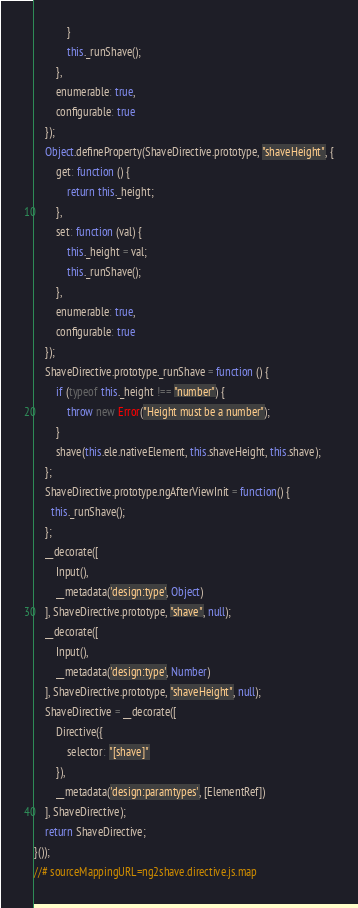Convert code to text. <code><loc_0><loc_0><loc_500><loc_500><_JavaScript_>            }
            this._runShave();
        },
        enumerable: true,
        configurable: true
    });
    Object.defineProperty(ShaveDirective.prototype, "shaveHeight", {
        get: function () {
            return this._height;
        },
        set: function (val) {
            this._height = val;
            this._runShave();
        },
        enumerable: true,
        configurable: true
    });
    ShaveDirective.prototype._runShave = function () {
        if (typeof this._height !== "number") {
            throw new Error("Height must be a number");
        }
        shave(this.ele.nativeElement, this.shaveHeight, this.shave);
    };
    ShaveDirective.prototype.ngAfterViewInit = function() {
      this._runShave();
    };
    __decorate([
        Input(), 
        __metadata('design:type', Object)
    ], ShaveDirective.prototype, "shave", null);
    __decorate([
        Input(), 
        __metadata('design:type', Number)
    ], ShaveDirective.prototype, "shaveHeight", null);
    ShaveDirective = __decorate([
        Directive({
            selector: "[shave]"
        }), 
        __metadata('design:paramtypes', [ElementRef])
    ], ShaveDirective);
    return ShaveDirective;
}());
//# sourceMappingURL=ng2shave.directive.js.map
</code> 